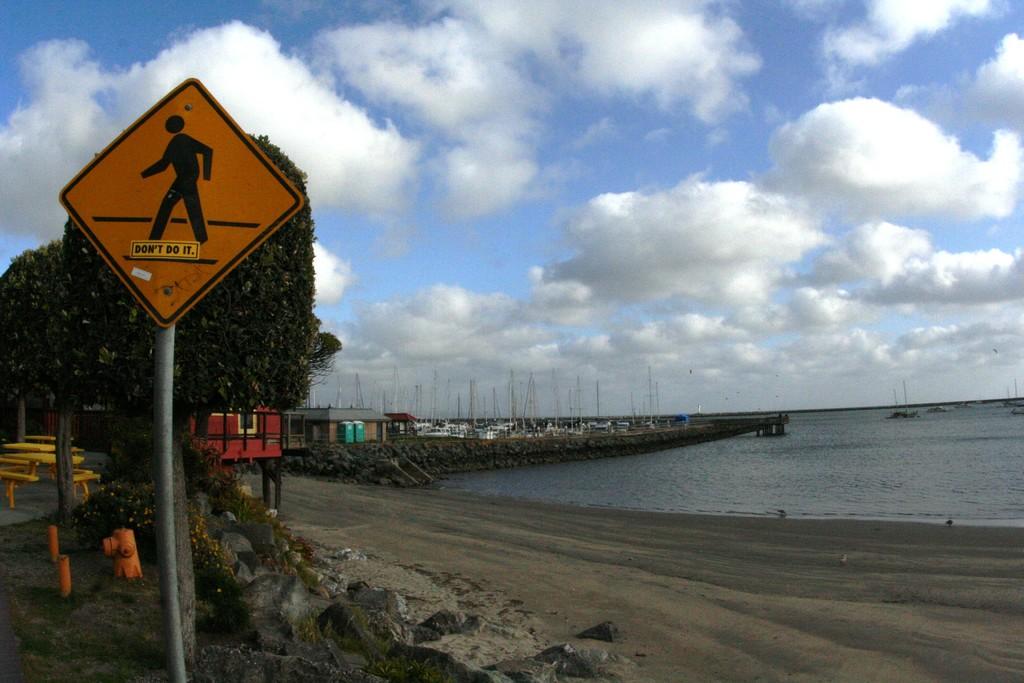What does the sticker on the pedestrian sign say?
Your response must be concise. Don't do it. 